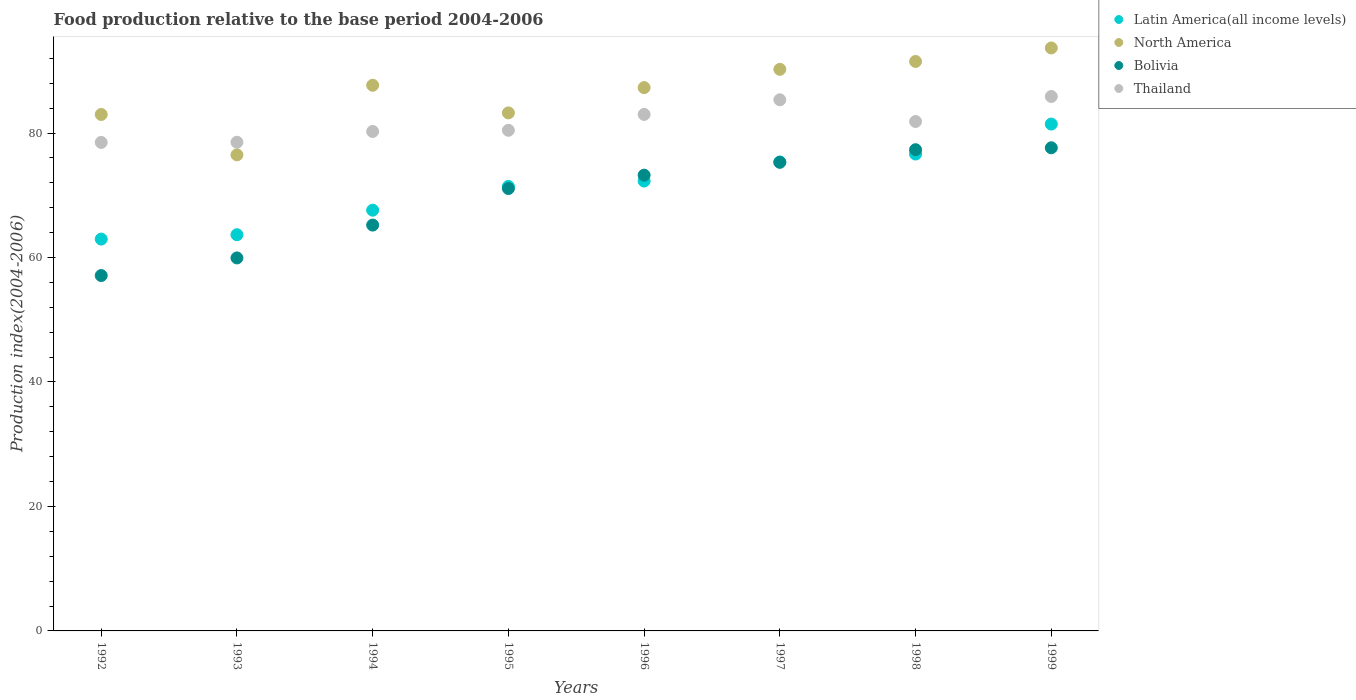What is the food production index in Thailand in 1997?
Your response must be concise. 85.34. Across all years, what is the maximum food production index in North America?
Ensure brevity in your answer.  93.67. Across all years, what is the minimum food production index in Thailand?
Your response must be concise. 78.49. In which year was the food production index in North America minimum?
Your response must be concise. 1993. What is the total food production index in Bolivia in the graph?
Give a very brief answer. 556.8. What is the difference between the food production index in Latin America(all income levels) in 1992 and that in 1998?
Provide a succinct answer. -13.67. What is the difference between the food production index in Latin America(all income levels) in 1992 and the food production index in Bolivia in 1999?
Your answer should be very brief. -14.67. What is the average food production index in Latin America(all income levels) per year?
Provide a short and direct response. 71.42. In the year 1993, what is the difference between the food production index in North America and food production index in Bolivia?
Ensure brevity in your answer.  16.56. In how many years, is the food production index in Thailand greater than 52?
Your answer should be compact. 8. What is the ratio of the food production index in North America in 1993 to that in 1996?
Your answer should be very brief. 0.88. What is the difference between the highest and the second highest food production index in Latin America(all income levels)?
Offer a very short reply. 4.81. What is the difference between the highest and the lowest food production index in Thailand?
Your answer should be compact. 7.38. Is it the case that in every year, the sum of the food production index in Bolivia and food production index in Latin America(all income levels)  is greater than the sum of food production index in North America and food production index in Thailand?
Your answer should be very brief. No. Is the food production index in Bolivia strictly less than the food production index in Latin America(all income levels) over the years?
Keep it short and to the point. No. How many dotlines are there?
Ensure brevity in your answer.  4. What is the difference between two consecutive major ticks on the Y-axis?
Your response must be concise. 20. Does the graph contain any zero values?
Provide a short and direct response. No. Does the graph contain grids?
Keep it short and to the point. No. Where does the legend appear in the graph?
Offer a very short reply. Top right. How are the legend labels stacked?
Ensure brevity in your answer.  Vertical. What is the title of the graph?
Your answer should be very brief. Food production relative to the base period 2004-2006. What is the label or title of the X-axis?
Keep it short and to the point. Years. What is the label or title of the Y-axis?
Give a very brief answer. Production index(2004-2006). What is the Production index(2004-2006) in Latin America(all income levels) in 1992?
Offer a terse response. 62.96. What is the Production index(2004-2006) in North America in 1992?
Your answer should be very brief. 82.98. What is the Production index(2004-2006) in Bolivia in 1992?
Ensure brevity in your answer.  57.1. What is the Production index(2004-2006) in Thailand in 1992?
Your response must be concise. 78.49. What is the Production index(2004-2006) in Latin America(all income levels) in 1993?
Ensure brevity in your answer.  63.66. What is the Production index(2004-2006) in North America in 1993?
Make the answer very short. 76.49. What is the Production index(2004-2006) in Bolivia in 1993?
Your answer should be compact. 59.93. What is the Production index(2004-2006) of Thailand in 1993?
Ensure brevity in your answer.  78.52. What is the Production index(2004-2006) in Latin America(all income levels) in 1994?
Ensure brevity in your answer.  67.6. What is the Production index(2004-2006) of North America in 1994?
Give a very brief answer. 87.67. What is the Production index(2004-2006) in Bolivia in 1994?
Your answer should be very brief. 65.21. What is the Production index(2004-2006) of Thailand in 1994?
Offer a very short reply. 80.25. What is the Production index(2004-2006) in Latin America(all income levels) in 1995?
Your answer should be compact. 71.42. What is the Production index(2004-2006) in North America in 1995?
Offer a very short reply. 83.24. What is the Production index(2004-2006) of Bolivia in 1995?
Offer a very short reply. 71.08. What is the Production index(2004-2006) of Thailand in 1995?
Your answer should be very brief. 80.44. What is the Production index(2004-2006) in Latin America(all income levels) in 1996?
Provide a short and direct response. 72.28. What is the Production index(2004-2006) of North America in 1996?
Your answer should be compact. 87.3. What is the Production index(2004-2006) in Bolivia in 1996?
Your answer should be compact. 73.23. What is the Production index(2004-2006) of Thailand in 1996?
Offer a terse response. 82.99. What is the Production index(2004-2006) in Latin America(all income levels) in 1997?
Your answer should be compact. 75.34. What is the Production index(2004-2006) of North America in 1997?
Give a very brief answer. 90.24. What is the Production index(2004-2006) of Bolivia in 1997?
Make the answer very short. 75.3. What is the Production index(2004-2006) of Thailand in 1997?
Provide a short and direct response. 85.34. What is the Production index(2004-2006) of Latin America(all income levels) in 1998?
Your response must be concise. 76.63. What is the Production index(2004-2006) in North America in 1998?
Provide a short and direct response. 91.5. What is the Production index(2004-2006) in Bolivia in 1998?
Your answer should be very brief. 77.32. What is the Production index(2004-2006) of Thailand in 1998?
Your answer should be compact. 81.85. What is the Production index(2004-2006) of Latin America(all income levels) in 1999?
Your answer should be very brief. 81.44. What is the Production index(2004-2006) of North America in 1999?
Provide a short and direct response. 93.67. What is the Production index(2004-2006) in Bolivia in 1999?
Your answer should be very brief. 77.63. What is the Production index(2004-2006) in Thailand in 1999?
Provide a succinct answer. 85.87. Across all years, what is the maximum Production index(2004-2006) in Latin America(all income levels)?
Keep it short and to the point. 81.44. Across all years, what is the maximum Production index(2004-2006) in North America?
Your answer should be very brief. 93.67. Across all years, what is the maximum Production index(2004-2006) of Bolivia?
Offer a terse response. 77.63. Across all years, what is the maximum Production index(2004-2006) in Thailand?
Keep it short and to the point. 85.87. Across all years, what is the minimum Production index(2004-2006) in Latin America(all income levels)?
Your response must be concise. 62.96. Across all years, what is the minimum Production index(2004-2006) in North America?
Provide a short and direct response. 76.49. Across all years, what is the minimum Production index(2004-2006) of Bolivia?
Your answer should be very brief. 57.1. Across all years, what is the minimum Production index(2004-2006) in Thailand?
Make the answer very short. 78.49. What is the total Production index(2004-2006) of Latin America(all income levels) in the graph?
Ensure brevity in your answer.  571.34. What is the total Production index(2004-2006) in North America in the graph?
Your answer should be compact. 693.08. What is the total Production index(2004-2006) of Bolivia in the graph?
Your answer should be compact. 556.8. What is the total Production index(2004-2006) of Thailand in the graph?
Make the answer very short. 653.75. What is the difference between the Production index(2004-2006) in Latin America(all income levels) in 1992 and that in 1993?
Offer a very short reply. -0.7. What is the difference between the Production index(2004-2006) of North America in 1992 and that in 1993?
Ensure brevity in your answer.  6.49. What is the difference between the Production index(2004-2006) in Bolivia in 1992 and that in 1993?
Provide a succinct answer. -2.83. What is the difference between the Production index(2004-2006) of Thailand in 1992 and that in 1993?
Your answer should be compact. -0.03. What is the difference between the Production index(2004-2006) in Latin America(all income levels) in 1992 and that in 1994?
Make the answer very short. -4.64. What is the difference between the Production index(2004-2006) of North America in 1992 and that in 1994?
Provide a succinct answer. -4.69. What is the difference between the Production index(2004-2006) of Bolivia in 1992 and that in 1994?
Your answer should be very brief. -8.11. What is the difference between the Production index(2004-2006) of Thailand in 1992 and that in 1994?
Provide a short and direct response. -1.76. What is the difference between the Production index(2004-2006) in Latin America(all income levels) in 1992 and that in 1995?
Make the answer very short. -8.46. What is the difference between the Production index(2004-2006) in North America in 1992 and that in 1995?
Your response must be concise. -0.26. What is the difference between the Production index(2004-2006) in Bolivia in 1992 and that in 1995?
Give a very brief answer. -13.98. What is the difference between the Production index(2004-2006) in Thailand in 1992 and that in 1995?
Offer a very short reply. -1.95. What is the difference between the Production index(2004-2006) in Latin America(all income levels) in 1992 and that in 1996?
Ensure brevity in your answer.  -9.32. What is the difference between the Production index(2004-2006) in North America in 1992 and that in 1996?
Offer a very short reply. -4.32. What is the difference between the Production index(2004-2006) in Bolivia in 1992 and that in 1996?
Offer a very short reply. -16.13. What is the difference between the Production index(2004-2006) of Thailand in 1992 and that in 1996?
Give a very brief answer. -4.5. What is the difference between the Production index(2004-2006) of Latin America(all income levels) in 1992 and that in 1997?
Provide a short and direct response. -12.38. What is the difference between the Production index(2004-2006) of North America in 1992 and that in 1997?
Ensure brevity in your answer.  -7.25. What is the difference between the Production index(2004-2006) in Bolivia in 1992 and that in 1997?
Make the answer very short. -18.2. What is the difference between the Production index(2004-2006) of Thailand in 1992 and that in 1997?
Provide a short and direct response. -6.85. What is the difference between the Production index(2004-2006) in Latin America(all income levels) in 1992 and that in 1998?
Provide a succinct answer. -13.67. What is the difference between the Production index(2004-2006) of North America in 1992 and that in 1998?
Give a very brief answer. -8.52. What is the difference between the Production index(2004-2006) of Bolivia in 1992 and that in 1998?
Your answer should be very brief. -20.22. What is the difference between the Production index(2004-2006) in Thailand in 1992 and that in 1998?
Keep it short and to the point. -3.36. What is the difference between the Production index(2004-2006) in Latin America(all income levels) in 1992 and that in 1999?
Offer a terse response. -18.48. What is the difference between the Production index(2004-2006) in North America in 1992 and that in 1999?
Make the answer very short. -10.69. What is the difference between the Production index(2004-2006) of Bolivia in 1992 and that in 1999?
Offer a very short reply. -20.53. What is the difference between the Production index(2004-2006) of Thailand in 1992 and that in 1999?
Make the answer very short. -7.38. What is the difference between the Production index(2004-2006) of Latin America(all income levels) in 1993 and that in 1994?
Your answer should be compact. -3.94. What is the difference between the Production index(2004-2006) in North America in 1993 and that in 1994?
Offer a terse response. -11.18. What is the difference between the Production index(2004-2006) in Bolivia in 1993 and that in 1994?
Make the answer very short. -5.28. What is the difference between the Production index(2004-2006) of Thailand in 1993 and that in 1994?
Provide a short and direct response. -1.73. What is the difference between the Production index(2004-2006) in Latin America(all income levels) in 1993 and that in 1995?
Offer a terse response. -7.76. What is the difference between the Production index(2004-2006) in North America in 1993 and that in 1995?
Make the answer very short. -6.74. What is the difference between the Production index(2004-2006) of Bolivia in 1993 and that in 1995?
Offer a very short reply. -11.15. What is the difference between the Production index(2004-2006) of Thailand in 1993 and that in 1995?
Your answer should be compact. -1.92. What is the difference between the Production index(2004-2006) of Latin America(all income levels) in 1993 and that in 1996?
Provide a short and direct response. -8.62. What is the difference between the Production index(2004-2006) in North America in 1993 and that in 1996?
Your answer should be very brief. -10.8. What is the difference between the Production index(2004-2006) in Thailand in 1993 and that in 1996?
Offer a very short reply. -4.47. What is the difference between the Production index(2004-2006) in Latin America(all income levels) in 1993 and that in 1997?
Provide a succinct answer. -11.68. What is the difference between the Production index(2004-2006) in North America in 1993 and that in 1997?
Your answer should be compact. -13.74. What is the difference between the Production index(2004-2006) of Bolivia in 1993 and that in 1997?
Make the answer very short. -15.37. What is the difference between the Production index(2004-2006) of Thailand in 1993 and that in 1997?
Ensure brevity in your answer.  -6.82. What is the difference between the Production index(2004-2006) of Latin America(all income levels) in 1993 and that in 1998?
Offer a terse response. -12.96. What is the difference between the Production index(2004-2006) in North America in 1993 and that in 1998?
Ensure brevity in your answer.  -15.01. What is the difference between the Production index(2004-2006) in Bolivia in 1993 and that in 1998?
Provide a short and direct response. -17.39. What is the difference between the Production index(2004-2006) of Thailand in 1993 and that in 1998?
Make the answer very short. -3.33. What is the difference between the Production index(2004-2006) in Latin America(all income levels) in 1993 and that in 1999?
Offer a very short reply. -17.78. What is the difference between the Production index(2004-2006) in North America in 1993 and that in 1999?
Ensure brevity in your answer.  -17.18. What is the difference between the Production index(2004-2006) of Bolivia in 1993 and that in 1999?
Your answer should be very brief. -17.7. What is the difference between the Production index(2004-2006) in Thailand in 1993 and that in 1999?
Ensure brevity in your answer.  -7.35. What is the difference between the Production index(2004-2006) in Latin America(all income levels) in 1994 and that in 1995?
Your answer should be very brief. -3.82. What is the difference between the Production index(2004-2006) of North America in 1994 and that in 1995?
Your answer should be compact. 4.44. What is the difference between the Production index(2004-2006) in Bolivia in 1994 and that in 1995?
Ensure brevity in your answer.  -5.87. What is the difference between the Production index(2004-2006) of Thailand in 1994 and that in 1995?
Offer a terse response. -0.19. What is the difference between the Production index(2004-2006) of Latin America(all income levels) in 1994 and that in 1996?
Your response must be concise. -4.68. What is the difference between the Production index(2004-2006) of North America in 1994 and that in 1996?
Keep it short and to the point. 0.38. What is the difference between the Production index(2004-2006) of Bolivia in 1994 and that in 1996?
Ensure brevity in your answer.  -8.02. What is the difference between the Production index(2004-2006) in Thailand in 1994 and that in 1996?
Your answer should be compact. -2.74. What is the difference between the Production index(2004-2006) in Latin America(all income levels) in 1994 and that in 1997?
Give a very brief answer. -7.74. What is the difference between the Production index(2004-2006) in North America in 1994 and that in 1997?
Make the answer very short. -2.56. What is the difference between the Production index(2004-2006) in Bolivia in 1994 and that in 1997?
Offer a very short reply. -10.09. What is the difference between the Production index(2004-2006) of Thailand in 1994 and that in 1997?
Keep it short and to the point. -5.09. What is the difference between the Production index(2004-2006) of Latin America(all income levels) in 1994 and that in 1998?
Provide a succinct answer. -9.02. What is the difference between the Production index(2004-2006) of North America in 1994 and that in 1998?
Ensure brevity in your answer.  -3.83. What is the difference between the Production index(2004-2006) of Bolivia in 1994 and that in 1998?
Make the answer very short. -12.11. What is the difference between the Production index(2004-2006) in Latin America(all income levels) in 1994 and that in 1999?
Offer a very short reply. -13.84. What is the difference between the Production index(2004-2006) in North America in 1994 and that in 1999?
Ensure brevity in your answer.  -6. What is the difference between the Production index(2004-2006) in Bolivia in 1994 and that in 1999?
Ensure brevity in your answer.  -12.42. What is the difference between the Production index(2004-2006) of Thailand in 1994 and that in 1999?
Provide a succinct answer. -5.62. What is the difference between the Production index(2004-2006) of Latin America(all income levels) in 1995 and that in 1996?
Offer a very short reply. -0.86. What is the difference between the Production index(2004-2006) in North America in 1995 and that in 1996?
Make the answer very short. -4.06. What is the difference between the Production index(2004-2006) in Bolivia in 1995 and that in 1996?
Offer a very short reply. -2.15. What is the difference between the Production index(2004-2006) in Thailand in 1995 and that in 1996?
Offer a very short reply. -2.55. What is the difference between the Production index(2004-2006) in Latin America(all income levels) in 1995 and that in 1997?
Offer a very short reply. -3.92. What is the difference between the Production index(2004-2006) in North America in 1995 and that in 1997?
Make the answer very short. -7. What is the difference between the Production index(2004-2006) in Bolivia in 1995 and that in 1997?
Provide a succinct answer. -4.22. What is the difference between the Production index(2004-2006) in Latin America(all income levels) in 1995 and that in 1998?
Offer a terse response. -5.21. What is the difference between the Production index(2004-2006) in North America in 1995 and that in 1998?
Offer a very short reply. -8.27. What is the difference between the Production index(2004-2006) in Bolivia in 1995 and that in 1998?
Offer a very short reply. -6.24. What is the difference between the Production index(2004-2006) in Thailand in 1995 and that in 1998?
Offer a terse response. -1.41. What is the difference between the Production index(2004-2006) of Latin America(all income levels) in 1995 and that in 1999?
Provide a succinct answer. -10.02. What is the difference between the Production index(2004-2006) of North America in 1995 and that in 1999?
Provide a succinct answer. -10.43. What is the difference between the Production index(2004-2006) of Bolivia in 1995 and that in 1999?
Your answer should be compact. -6.55. What is the difference between the Production index(2004-2006) in Thailand in 1995 and that in 1999?
Provide a succinct answer. -5.43. What is the difference between the Production index(2004-2006) of Latin America(all income levels) in 1996 and that in 1997?
Provide a succinct answer. -3.06. What is the difference between the Production index(2004-2006) of North America in 1996 and that in 1997?
Offer a very short reply. -2.94. What is the difference between the Production index(2004-2006) in Bolivia in 1996 and that in 1997?
Give a very brief answer. -2.07. What is the difference between the Production index(2004-2006) of Thailand in 1996 and that in 1997?
Keep it short and to the point. -2.35. What is the difference between the Production index(2004-2006) of Latin America(all income levels) in 1996 and that in 1998?
Offer a very short reply. -4.34. What is the difference between the Production index(2004-2006) in North America in 1996 and that in 1998?
Make the answer very short. -4.21. What is the difference between the Production index(2004-2006) in Bolivia in 1996 and that in 1998?
Offer a very short reply. -4.09. What is the difference between the Production index(2004-2006) of Thailand in 1996 and that in 1998?
Keep it short and to the point. 1.14. What is the difference between the Production index(2004-2006) in Latin America(all income levels) in 1996 and that in 1999?
Ensure brevity in your answer.  -9.16. What is the difference between the Production index(2004-2006) in North America in 1996 and that in 1999?
Provide a short and direct response. -6.37. What is the difference between the Production index(2004-2006) in Thailand in 1996 and that in 1999?
Ensure brevity in your answer.  -2.88. What is the difference between the Production index(2004-2006) of Latin America(all income levels) in 1997 and that in 1998?
Provide a succinct answer. -1.28. What is the difference between the Production index(2004-2006) of North America in 1997 and that in 1998?
Your answer should be very brief. -1.27. What is the difference between the Production index(2004-2006) in Bolivia in 1997 and that in 1998?
Provide a succinct answer. -2.02. What is the difference between the Production index(2004-2006) of Thailand in 1997 and that in 1998?
Ensure brevity in your answer.  3.49. What is the difference between the Production index(2004-2006) in Latin America(all income levels) in 1997 and that in 1999?
Your response must be concise. -6.1. What is the difference between the Production index(2004-2006) of North America in 1997 and that in 1999?
Your answer should be compact. -3.43. What is the difference between the Production index(2004-2006) of Bolivia in 1997 and that in 1999?
Provide a short and direct response. -2.33. What is the difference between the Production index(2004-2006) in Thailand in 1997 and that in 1999?
Offer a terse response. -0.53. What is the difference between the Production index(2004-2006) of Latin America(all income levels) in 1998 and that in 1999?
Make the answer very short. -4.81. What is the difference between the Production index(2004-2006) in North America in 1998 and that in 1999?
Provide a short and direct response. -2.17. What is the difference between the Production index(2004-2006) of Bolivia in 1998 and that in 1999?
Your response must be concise. -0.31. What is the difference between the Production index(2004-2006) of Thailand in 1998 and that in 1999?
Your answer should be very brief. -4.02. What is the difference between the Production index(2004-2006) in Latin America(all income levels) in 1992 and the Production index(2004-2006) in North America in 1993?
Make the answer very short. -13.53. What is the difference between the Production index(2004-2006) of Latin America(all income levels) in 1992 and the Production index(2004-2006) of Bolivia in 1993?
Your answer should be very brief. 3.03. What is the difference between the Production index(2004-2006) in Latin America(all income levels) in 1992 and the Production index(2004-2006) in Thailand in 1993?
Ensure brevity in your answer.  -15.56. What is the difference between the Production index(2004-2006) in North America in 1992 and the Production index(2004-2006) in Bolivia in 1993?
Make the answer very short. 23.05. What is the difference between the Production index(2004-2006) of North America in 1992 and the Production index(2004-2006) of Thailand in 1993?
Your answer should be compact. 4.46. What is the difference between the Production index(2004-2006) in Bolivia in 1992 and the Production index(2004-2006) in Thailand in 1993?
Your answer should be very brief. -21.42. What is the difference between the Production index(2004-2006) in Latin America(all income levels) in 1992 and the Production index(2004-2006) in North America in 1994?
Ensure brevity in your answer.  -24.71. What is the difference between the Production index(2004-2006) in Latin America(all income levels) in 1992 and the Production index(2004-2006) in Bolivia in 1994?
Keep it short and to the point. -2.25. What is the difference between the Production index(2004-2006) in Latin America(all income levels) in 1992 and the Production index(2004-2006) in Thailand in 1994?
Provide a short and direct response. -17.29. What is the difference between the Production index(2004-2006) in North America in 1992 and the Production index(2004-2006) in Bolivia in 1994?
Give a very brief answer. 17.77. What is the difference between the Production index(2004-2006) in North America in 1992 and the Production index(2004-2006) in Thailand in 1994?
Provide a short and direct response. 2.73. What is the difference between the Production index(2004-2006) in Bolivia in 1992 and the Production index(2004-2006) in Thailand in 1994?
Your answer should be very brief. -23.15. What is the difference between the Production index(2004-2006) of Latin America(all income levels) in 1992 and the Production index(2004-2006) of North America in 1995?
Offer a terse response. -20.28. What is the difference between the Production index(2004-2006) in Latin America(all income levels) in 1992 and the Production index(2004-2006) in Bolivia in 1995?
Ensure brevity in your answer.  -8.12. What is the difference between the Production index(2004-2006) of Latin America(all income levels) in 1992 and the Production index(2004-2006) of Thailand in 1995?
Provide a short and direct response. -17.48. What is the difference between the Production index(2004-2006) of North America in 1992 and the Production index(2004-2006) of Bolivia in 1995?
Offer a terse response. 11.9. What is the difference between the Production index(2004-2006) of North America in 1992 and the Production index(2004-2006) of Thailand in 1995?
Offer a very short reply. 2.54. What is the difference between the Production index(2004-2006) of Bolivia in 1992 and the Production index(2004-2006) of Thailand in 1995?
Provide a short and direct response. -23.34. What is the difference between the Production index(2004-2006) in Latin America(all income levels) in 1992 and the Production index(2004-2006) in North America in 1996?
Keep it short and to the point. -24.34. What is the difference between the Production index(2004-2006) of Latin America(all income levels) in 1992 and the Production index(2004-2006) of Bolivia in 1996?
Offer a very short reply. -10.27. What is the difference between the Production index(2004-2006) of Latin America(all income levels) in 1992 and the Production index(2004-2006) of Thailand in 1996?
Provide a short and direct response. -20.03. What is the difference between the Production index(2004-2006) of North America in 1992 and the Production index(2004-2006) of Bolivia in 1996?
Ensure brevity in your answer.  9.75. What is the difference between the Production index(2004-2006) in North America in 1992 and the Production index(2004-2006) in Thailand in 1996?
Your answer should be very brief. -0.01. What is the difference between the Production index(2004-2006) of Bolivia in 1992 and the Production index(2004-2006) of Thailand in 1996?
Make the answer very short. -25.89. What is the difference between the Production index(2004-2006) in Latin America(all income levels) in 1992 and the Production index(2004-2006) in North America in 1997?
Give a very brief answer. -27.27. What is the difference between the Production index(2004-2006) of Latin America(all income levels) in 1992 and the Production index(2004-2006) of Bolivia in 1997?
Your answer should be compact. -12.34. What is the difference between the Production index(2004-2006) of Latin America(all income levels) in 1992 and the Production index(2004-2006) of Thailand in 1997?
Keep it short and to the point. -22.38. What is the difference between the Production index(2004-2006) in North America in 1992 and the Production index(2004-2006) in Bolivia in 1997?
Ensure brevity in your answer.  7.68. What is the difference between the Production index(2004-2006) in North America in 1992 and the Production index(2004-2006) in Thailand in 1997?
Offer a terse response. -2.36. What is the difference between the Production index(2004-2006) in Bolivia in 1992 and the Production index(2004-2006) in Thailand in 1997?
Give a very brief answer. -28.24. What is the difference between the Production index(2004-2006) of Latin America(all income levels) in 1992 and the Production index(2004-2006) of North America in 1998?
Your response must be concise. -28.54. What is the difference between the Production index(2004-2006) in Latin America(all income levels) in 1992 and the Production index(2004-2006) in Bolivia in 1998?
Your response must be concise. -14.36. What is the difference between the Production index(2004-2006) in Latin America(all income levels) in 1992 and the Production index(2004-2006) in Thailand in 1998?
Make the answer very short. -18.89. What is the difference between the Production index(2004-2006) of North America in 1992 and the Production index(2004-2006) of Bolivia in 1998?
Your response must be concise. 5.66. What is the difference between the Production index(2004-2006) in North America in 1992 and the Production index(2004-2006) in Thailand in 1998?
Offer a terse response. 1.13. What is the difference between the Production index(2004-2006) of Bolivia in 1992 and the Production index(2004-2006) of Thailand in 1998?
Ensure brevity in your answer.  -24.75. What is the difference between the Production index(2004-2006) of Latin America(all income levels) in 1992 and the Production index(2004-2006) of North America in 1999?
Ensure brevity in your answer.  -30.71. What is the difference between the Production index(2004-2006) of Latin America(all income levels) in 1992 and the Production index(2004-2006) of Bolivia in 1999?
Your answer should be very brief. -14.67. What is the difference between the Production index(2004-2006) of Latin America(all income levels) in 1992 and the Production index(2004-2006) of Thailand in 1999?
Give a very brief answer. -22.91. What is the difference between the Production index(2004-2006) in North America in 1992 and the Production index(2004-2006) in Bolivia in 1999?
Keep it short and to the point. 5.35. What is the difference between the Production index(2004-2006) of North America in 1992 and the Production index(2004-2006) of Thailand in 1999?
Provide a succinct answer. -2.89. What is the difference between the Production index(2004-2006) of Bolivia in 1992 and the Production index(2004-2006) of Thailand in 1999?
Provide a short and direct response. -28.77. What is the difference between the Production index(2004-2006) of Latin America(all income levels) in 1993 and the Production index(2004-2006) of North America in 1994?
Make the answer very short. -24.01. What is the difference between the Production index(2004-2006) in Latin America(all income levels) in 1993 and the Production index(2004-2006) in Bolivia in 1994?
Provide a succinct answer. -1.55. What is the difference between the Production index(2004-2006) in Latin America(all income levels) in 1993 and the Production index(2004-2006) in Thailand in 1994?
Offer a very short reply. -16.59. What is the difference between the Production index(2004-2006) of North America in 1993 and the Production index(2004-2006) of Bolivia in 1994?
Make the answer very short. 11.28. What is the difference between the Production index(2004-2006) in North America in 1993 and the Production index(2004-2006) in Thailand in 1994?
Offer a very short reply. -3.76. What is the difference between the Production index(2004-2006) in Bolivia in 1993 and the Production index(2004-2006) in Thailand in 1994?
Keep it short and to the point. -20.32. What is the difference between the Production index(2004-2006) of Latin America(all income levels) in 1993 and the Production index(2004-2006) of North America in 1995?
Offer a terse response. -19.57. What is the difference between the Production index(2004-2006) of Latin America(all income levels) in 1993 and the Production index(2004-2006) of Bolivia in 1995?
Your response must be concise. -7.42. What is the difference between the Production index(2004-2006) in Latin America(all income levels) in 1993 and the Production index(2004-2006) in Thailand in 1995?
Provide a succinct answer. -16.78. What is the difference between the Production index(2004-2006) in North America in 1993 and the Production index(2004-2006) in Bolivia in 1995?
Offer a terse response. 5.41. What is the difference between the Production index(2004-2006) in North America in 1993 and the Production index(2004-2006) in Thailand in 1995?
Give a very brief answer. -3.95. What is the difference between the Production index(2004-2006) of Bolivia in 1993 and the Production index(2004-2006) of Thailand in 1995?
Offer a very short reply. -20.51. What is the difference between the Production index(2004-2006) in Latin America(all income levels) in 1993 and the Production index(2004-2006) in North America in 1996?
Keep it short and to the point. -23.63. What is the difference between the Production index(2004-2006) of Latin America(all income levels) in 1993 and the Production index(2004-2006) of Bolivia in 1996?
Keep it short and to the point. -9.57. What is the difference between the Production index(2004-2006) of Latin America(all income levels) in 1993 and the Production index(2004-2006) of Thailand in 1996?
Offer a terse response. -19.33. What is the difference between the Production index(2004-2006) of North America in 1993 and the Production index(2004-2006) of Bolivia in 1996?
Your response must be concise. 3.26. What is the difference between the Production index(2004-2006) of North America in 1993 and the Production index(2004-2006) of Thailand in 1996?
Offer a very short reply. -6.5. What is the difference between the Production index(2004-2006) of Bolivia in 1993 and the Production index(2004-2006) of Thailand in 1996?
Give a very brief answer. -23.06. What is the difference between the Production index(2004-2006) in Latin America(all income levels) in 1993 and the Production index(2004-2006) in North America in 1997?
Your response must be concise. -26.57. What is the difference between the Production index(2004-2006) of Latin America(all income levels) in 1993 and the Production index(2004-2006) of Bolivia in 1997?
Ensure brevity in your answer.  -11.64. What is the difference between the Production index(2004-2006) of Latin America(all income levels) in 1993 and the Production index(2004-2006) of Thailand in 1997?
Make the answer very short. -21.68. What is the difference between the Production index(2004-2006) in North America in 1993 and the Production index(2004-2006) in Bolivia in 1997?
Keep it short and to the point. 1.19. What is the difference between the Production index(2004-2006) in North America in 1993 and the Production index(2004-2006) in Thailand in 1997?
Provide a succinct answer. -8.85. What is the difference between the Production index(2004-2006) of Bolivia in 1993 and the Production index(2004-2006) of Thailand in 1997?
Your answer should be very brief. -25.41. What is the difference between the Production index(2004-2006) of Latin America(all income levels) in 1993 and the Production index(2004-2006) of North America in 1998?
Offer a terse response. -27.84. What is the difference between the Production index(2004-2006) in Latin America(all income levels) in 1993 and the Production index(2004-2006) in Bolivia in 1998?
Offer a very short reply. -13.66. What is the difference between the Production index(2004-2006) in Latin America(all income levels) in 1993 and the Production index(2004-2006) in Thailand in 1998?
Make the answer very short. -18.19. What is the difference between the Production index(2004-2006) of North America in 1993 and the Production index(2004-2006) of Bolivia in 1998?
Your response must be concise. -0.83. What is the difference between the Production index(2004-2006) in North America in 1993 and the Production index(2004-2006) in Thailand in 1998?
Make the answer very short. -5.36. What is the difference between the Production index(2004-2006) of Bolivia in 1993 and the Production index(2004-2006) of Thailand in 1998?
Offer a terse response. -21.92. What is the difference between the Production index(2004-2006) of Latin America(all income levels) in 1993 and the Production index(2004-2006) of North America in 1999?
Offer a terse response. -30.01. What is the difference between the Production index(2004-2006) of Latin America(all income levels) in 1993 and the Production index(2004-2006) of Bolivia in 1999?
Give a very brief answer. -13.97. What is the difference between the Production index(2004-2006) in Latin America(all income levels) in 1993 and the Production index(2004-2006) in Thailand in 1999?
Your answer should be very brief. -22.21. What is the difference between the Production index(2004-2006) of North America in 1993 and the Production index(2004-2006) of Bolivia in 1999?
Provide a short and direct response. -1.14. What is the difference between the Production index(2004-2006) in North America in 1993 and the Production index(2004-2006) in Thailand in 1999?
Your answer should be very brief. -9.38. What is the difference between the Production index(2004-2006) in Bolivia in 1993 and the Production index(2004-2006) in Thailand in 1999?
Give a very brief answer. -25.94. What is the difference between the Production index(2004-2006) of Latin America(all income levels) in 1994 and the Production index(2004-2006) of North America in 1995?
Offer a very short reply. -15.63. What is the difference between the Production index(2004-2006) in Latin America(all income levels) in 1994 and the Production index(2004-2006) in Bolivia in 1995?
Give a very brief answer. -3.48. What is the difference between the Production index(2004-2006) of Latin America(all income levels) in 1994 and the Production index(2004-2006) of Thailand in 1995?
Offer a terse response. -12.84. What is the difference between the Production index(2004-2006) in North America in 1994 and the Production index(2004-2006) in Bolivia in 1995?
Your answer should be very brief. 16.59. What is the difference between the Production index(2004-2006) of North America in 1994 and the Production index(2004-2006) of Thailand in 1995?
Make the answer very short. 7.23. What is the difference between the Production index(2004-2006) of Bolivia in 1994 and the Production index(2004-2006) of Thailand in 1995?
Offer a terse response. -15.23. What is the difference between the Production index(2004-2006) of Latin America(all income levels) in 1994 and the Production index(2004-2006) of North America in 1996?
Keep it short and to the point. -19.69. What is the difference between the Production index(2004-2006) in Latin America(all income levels) in 1994 and the Production index(2004-2006) in Bolivia in 1996?
Your answer should be very brief. -5.63. What is the difference between the Production index(2004-2006) of Latin America(all income levels) in 1994 and the Production index(2004-2006) of Thailand in 1996?
Your answer should be very brief. -15.39. What is the difference between the Production index(2004-2006) of North America in 1994 and the Production index(2004-2006) of Bolivia in 1996?
Keep it short and to the point. 14.44. What is the difference between the Production index(2004-2006) in North America in 1994 and the Production index(2004-2006) in Thailand in 1996?
Provide a short and direct response. 4.68. What is the difference between the Production index(2004-2006) of Bolivia in 1994 and the Production index(2004-2006) of Thailand in 1996?
Your answer should be very brief. -17.78. What is the difference between the Production index(2004-2006) of Latin America(all income levels) in 1994 and the Production index(2004-2006) of North America in 1997?
Provide a short and direct response. -22.63. What is the difference between the Production index(2004-2006) in Latin America(all income levels) in 1994 and the Production index(2004-2006) in Bolivia in 1997?
Your response must be concise. -7.7. What is the difference between the Production index(2004-2006) in Latin America(all income levels) in 1994 and the Production index(2004-2006) in Thailand in 1997?
Your response must be concise. -17.74. What is the difference between the Production index(2004-2006) of North America in 1994 and the Production index(2004-2006) of Bolivia in 1997?
Your response must be concise. 12.37. What is the difference between the Production index(2004-2006) of North America in 1994 and the Production index(2004-2006) of Thailand in 1997?
Give a very brief answer. 2.33. What is the difference between the Production index(2004-2006) in Bolivia in 1994 and the Production index(2004-2006) in Thailand in 1997?
Make the answer very short. -20.13. What is the difference between the Production index(2004-2006) of Latin America(all income levels) in 1994 and the Production index(2004-2006) of North America in 1998?
Keep it short and to the point. -23.9. What is the difference between the Production index(2004-2006) in Latin America(all income levels) in 1994 and the Production index(2004-2006) in Bolivia in 1998?
Your answer should be compact. -9.72. What is the difference between the Production index(2004-2006) of Latin America(all income levels) in 1994 and the Production index(2004-2006) of Thailand in 1998?
Your answer should be compact. -14.25. What is the difference between the Production index(2004-2006) in North America in 1994 and the Production index(2004-2006) in Bolivia in 1998?
Give a very brief answer. 10.35. What is the difference between the Production index(2004-2006) of North America in 1994 and the Production index(2004-2006) of Thailand in 1998?
Give a very brief answer. 5.82. What is the difference between the Production index(2004-2006) in Bolivia in 1994 and the Production index(2004-2006) in Thailand in 1998?
Provide a succinct answer. -16.64. What is the difference between the Production index(2004-2006) of Latin America(all income levels) in 1994 and the Production index(2004-2006) of North America in 1999?
Your answer should be compact. -26.07. What is the difference between the Production index(2004-2006) of Latin America(all income levels) in 1994 and the Production index(2004-2006) of Bolivia in 1999?
Make the answer very short. -10.03. What is the difference between the Production index(2004-2006) in Latin America(all income levels) in 1994 and the Production index(2004-2006) in Thailand in 1999?
Your answer should be very brief. -18.27. What is the difference between the Production index(2004-2006) in North America in 1994 and the Production index(2004-2006) in Bolivia in 1999?
Ensure brevity in your answer.  10.04. What is the difference between the Production index(2004-2006) in North America in 1994 and the Production index(2004-2006) in Thailand in 1999?
Keep it short and to the point. 1.8. What is the difference between the Production index(2004-2006) in Bolivia in 1994 and the Production index(2004-2006) in Thailand in 1999?
Ensure brevity in your answer.  -20.66. What is the difference between the Production index(2004-2006) in Latin America(all income levels) in 1995 and the Production index(2004-2006) in North America in 1996?
Give a very brief answer. -15.88. What is the difference between the Production index(2004-2006) in Latin America(all income levels) in 1995 and the Production index(2004-2006) in Bolivia in 1996?
Keep it short and to the point. -1.81. What is the difference between the Production index(2004-2006) of Latin America(all income levels) in 1995 and the Production index(2004-2006) of Thailand in 1996?
Make the answer very short. -11.57. What is the difference between the Production index(2004-2006) of North America in 1995 and the Production index(2004-2006) of Bolivia in 1996?
Give a very brief answer. 10.01. What is the difference between the Production index(2004-2006) of North America in 1995 and the Production index(2004-2006) of Thailand in 1996?
Keep it short and to the point. 0.25. What is the difference between the Production index(2004-2006) in Bolivia in 1995 and the Production index(2004-2006) in Thailand in 1996?
Offer a very short reply. -11.91. What is the difference between the Production index(2004-2006) in Latin America(all income levels) in 1995 and the Production index(2004-2006) in North America in 1997?
Ensure brevity in your answer.  -18.82. What is the difference between the Production index(2004-2006) of Latin America(all income levels) in 1995 and the Production index(2004-2006) of Bolivia in 1997?
Provide a short and direct response. -3.88. What is the difference between the Production index(2004-2006) in Latin America(all income levels) in 1995 and the Production index(2004-2006) in Thailand in 1997?
Give a very brief answer. -13.92. What is the difference between the Production index(2004-2006) in North America in 1995 and the Production index(2004-2006) in Bolivia in 1997?
Your answer should be very brief. 7.94. What is the difference between the Production index(2004-2006) in North America in 1995 and the Production index(2004-2006) in Thailand in 1997?
Give a very brief answer. -2.1. What is the difference between the Production index(2004-2006) in Bolivia in 1995 and the Production index(2004-2006) in Thailand in 1997?
Provide a succinct answer. -14.26. What is the difference between the Production index(2004-2006) of Latin America(all income levels) in 1995 and the Production index(2004-2006) of North America in 1998?
Provide a succinct answer. -20.08. What is the difference between the Production index(2004-2006) in Latin America(all income levels) in 1995 and the Production index(2004-2006) in Bolivia in 1998?
Offer a terse response. -5.9. What is the difference between the Production index(2004-2006) in Latin America(all income levels) in 1995 and the Production index(2004-2006) in Thailand in 1998?
Make the answer very short. -10.43. What is the difference between the Production index(2004-2006) in North America in 1995 and the Production index(2004-2006) in Bolivia in 1998?
Keep it short and to the point. 5.92. What is the difference between the Production index(2004-2006) of North America in 1995 and the Production index(2004-2006) of Thailand in 1998?
Keep it short and to the point. 1.39. What is the difference between the Production index(2004-2006) of Bolivia in 1995 and the Production index(2004-2006) of Thailand in 1998?
Offer a very short reply. -10.77. What is the difference between the Production index(2004-2006) of Latin America(all income levels) in 1995 and the Production index(2004-2006) of North America in 1999?
Your answer should be compact. -22.25. What is the difference between the Production index(2004-2006) in Latin America(all income levels) in 1995 and the Production index(2004-2006) in Bolivia in 1999?
Offer a very short reply. -6.21. What is the difference between the Production index(2004-2006) in Latin America(all income levels) in 1995 and the Production index(2004-2006) in Thailand in 1999?
Provide a short and direct response. -14.45. What is the difference between the Production index(2004-2006) in North America in 1995 and the Production index(2004-2006) in Bolivia in 1999?
Your response must be concise. 5.61. What is the difference between the Production index(2004-2006) in North America in 1995 and the Production index(2004-2006) in Thailand in 1999?
Your response must be concise. -2.63. What is the difference between the Production index(2004-2006) in Bolivia in 1995 and the Production index(2004-2006) in Thailand in 1999?
Make the answer very short. -14.79. What is the difference between the Production index(2004-2006) of Latin America(all income levels) in 1996 and the Production index(2004-2006) of North America in 1997?
Your response must be concise. -17.95. What is the difference between the Production index(2004-2006) in Latin America(all income levels) in 1996 and the Production index(2004-2006) in Bolivia in 1997?
Offer a very short reply. -3.02. What is the difference between the Production index(2004-2006) in Latin America(all income levels) in 1996 and the Production index(2004-2006) in Thailand in 1997?
Ensure brevity in your answer.  -13.06. What is the difference between the Production index(2004-2006) of North America in 1996 and the Production index(2004-2006) of Bolivia in 1997?
Make the answer very short. 12. What is the difference between the Production index(2004-2006) of North America in 1996 and the Production index(2004-2006) of Thailand in 1997?
Make the answer very short. 1.96. What is the difference between the Production index(2004-2006) of Bolivia in 1996 and the Production index(2004-2006) of Thailand in 1997?
Your answer should be very brief. -12.11. What is the difference between the Production index(2004-2006) in Latin America(all income levels) in 1996 and the Production index(2004-2006) in North America in 1998?
Your answer should be very brief. -19.22. What is the difference between the Production index(2004-2006) of Latin America(all income levels) in 1996 and the Production index(2004-2006) of Bolivia in 1998?
Give a very brief answer. -5.04. What is the difference between the Production index(2004-2006) in Latin America(all income levels) in 1996 and the Production index(2004-2006) in Thailand in 1998?
Your response must be concise. -9.57. What is the difference between the Production index(2004-2006) in North America in 1996 and the Production index(2004-2006) in Bolivia in 1998?
Your answer should be compact. 9.98. What is the difference between the Production index(2004-2006) in North America in 1996 and the Production index(2004-2006) in Thailand in 1998?
Ensure brevity in your answer.  5.45. What is the difference between the Production index(2004-2006) in Bolivia in 1996 and the Production index(2004-2006) in Thailand in 1998?
Offer a very short reply. -8.62. What is the difference between the Production index(2004-2006) in Latin America(all income levels) in 1996 and the Production index(2004-2006) in North America in 1999?
Provide a short and direct response. -21.39. What is the difference between the Production index(2004-2006) in Latin America(all income levels) in 1996 and the Production index(2004-2006) in Bolivia in 1999?
Your answer should be very brief. -5.35. What is the difference between the Production index(2004-2006) of Latin America(all income levels) in 1996 and the Production index(2004-2006) of Thailand in 1999?
Provide a short and direct response. -13.59. What is the difference between the Production index(2004-2006) of North America in 1996 and the Production index(2004-2006) of Bolivia in 1999?
Offer a very short reply. 9.67. What is the difference between the Production index(2004-2006) of North America in 1996 and the Production index(2004-2006) of Thailand in 1999?
Provide a succinct answer. 1.43. What is the difference between the Production index(2004-2006) in Bolivia in 1996 and the Production index(2004-2006) in Thailand in 1999?
Ensure brevity in your answer.  -12.64. What is the difference between the Production index(2004-2006) of Latin America(all income levels) in 1997 and the Production index(2004-2006) of North America in 1998?
Keep it short and to the point. -16.16. What is the difference between the Production index(2004-2006) in Latin America(all income levels) in 1997 and the Production index(2004-2006) in Bolivia in 1998?
Ensure brevity in your answer.  -1.98. What is the difference between the Production index(2004-2006) in Latin America(all income levels) in 1997 and the Production index(2004-2006) in Thailand in 1998?
Your answer should be very brief. -6.51. What is the difference between the Production index(2004-2006) in North America in 1997 and the Production index(2004-2006) in Bolivia in 1998?
Provide a succinct answer. 12.92. What is the difference between the Production index(2004-2006) of North America in 1997 and the Production index(2004-2006) of Thailand in 1998?
Your response must be concise. 8.39. What is the difference between the Production index(2004-2006) in Bolivia in 1997 and the Production index(2004-2006) in Thailand in 1998?
Offer a very short reply. -6.55. What is the difference between the Production index(2004-2006) in Latin America(all income levels) in 1997 and the Production index(2004-2006) in North America in 1999?
Provide a succinct answer. -18.33. What is the difference between the Production index(2004-2006) in Latin America(all income levels) in 1997 and the Production index(2004-2006) in Bolivia in 1999?
Give a very brief answer. -2.29. What is the difference between the Production index(2004-2006) of Latin America(all income levels) in 1997 and the Production index(2004-2006) of Thailand in 1999?
Offer a very short reply. -10.53. What is the difference between the Production index(2004-2006) in North America in 1997 and the Production index(2004-2006) in Bolivia in 1999?
Ensure brevity in your answer.  12.61. What is the difference between the Production index(2004-2006) in North America in 1997 and the Production index(2004-2006) in Thailand in 1999?
Provide a succinct answer. 4.37. What is the difference between the Production index(2004-2006) of Bolivia in 1997 and the Production index(2004-2006) of Thailand in 1999?
Keep it short and to the point. -10.57. What is the difference between the Production index(2004-2006) of Latin America(all income levels) in 1998 and the Production index(2004-2006) of North America in 1999?
Keep it short and to the point. -17.04. What is the difference between the Production index(2004-2006) in Latin America(all income levels) in 1998 and the Production index(2004-2006) in Bolivia in 1999?
Your answer should be very brief. -1. What is the difference between the Production index(2004-2006) of Latin America(all income levels) in 1998 and the Production index(2004-2006) of Thailand in 1999?
Provide a succinct answer. -9.24. What is the difference between the Production index(2004-2006) in North America in 1998 and the Production index(2004-2006) in Bolivia in 1999?
Your answer should be very brief. 13.87. What is the difference between the Production index(2004-2006) of North America in 1998 and the Production index(2004-2006) of Thailand in 1999?
Provide a succinct answer. 5.63. What is the difference between the Production index(2004-2006) in Bolivia in 1998 and the Production index(2004-2006) in Thailand in 1999?
Make the answer very short. -8.55. What is the average Production index(2004-2006) of Latin America(all income levels) per year?
Ensure brevity in your answer.  71.42. What is the average Production index(2004-2006) of North America per year?
Offer a terse response. 86.64. What is the average Production index(2004-2006) in Bolivia per year?
Provide a succinct answer. 69.6. What is the average Production index(2004-2006) of Thailand per year?
Provide a short and direct response. 81.72. In the year 1992, what is the difference between the Production index(2004-2006) in Latin America(all income levels) and Production index(2004-2006) in North America?
Provide a succinct answer. -20.02. In the year 1992, what is the difference between the Production index(2004-2006) of Latin America(all income levels) and Production index(2004-2006) of Bolivia?
Make the answer very short. 5.86. In the year 1992, what is the difference between the Production index(2004-2006) of Latin America(all income levels) and Production index(2004-2006) of Thailand?
Offer a terse response. -15.53. In the year 1992, what is the difference between the Production index(2004-2006) in North America and Production index(2004-2006) in Bolivia?
Provide a succinct answer. 25.88. In the year 1992, what is the difference between the Production index(2004-2006) in North America and Production index(2004-2006) in Thailand?
Your response must be concise. 4.49. In the year 1992, what is the difference between the Production index(2004-2006) in Bolivia and Production index(2004-2006) in Thailand?
Your answer should be very brief. -21.39. In the year 1993, what is the difference between the Production index(2004-2006) of Latin America(all income levels) and Production index(2004-2006) of North America?
Offer a very short reply. -12.83. In the year 1993, what is the difference between the Production index(2004-2006) of Latin America(all income levels) and Production index(2004-2006) of Bolivia?
Ensure brevity in your answer.  3.73. In the year 1993, what is the difference between the Production index(2004-2006) of Latin America(all income levels) and Production index(2004-2006) of Thailand?
Give a very brief answer. -14.86. In the year 1993, what is the difference between the Production index(2004-2006) of North America and Production index(2004-2006) of Bolivia?
Offer a very short reply. 16.56. In the year 1993, what is the difference between the Production index(2004-2006) of North America and Production index(2004-2006) of Thailand?
Provide a short and direct response. -2.03. In the year 1993, what is the difference between the Production index(2004-2006) in Bolivia and Production index(2004-2006) in Thailand?
Your answer should be compact. -18.59. In the year 1994, what is the difference between the Production index(2004-2006) of Latin America(all income levels) and Production index(2004-2006) of North America?
Ensure brevity in your answer.  -20.07. In the year 1994, what is the difference between the Production index(2004-2006) of Latin America(all income levels) and Production index(2004-2006) of Bolivia?
Keep it short and to the point. 2.39. In the year 1994, what is the difference between the Production index(2004-2006) in Latin America(all income levels) and Production index(2004-2006) in Thailand?
Provide a short and direct response. -12.65. In the year 1994, what is the difference between the Production index(2004-2006) in North America and Production index(2004-2006) in Bolivia?
Offer a terse response. 22.46. In the year 1994, what is the difference between the Production index(2004-2006) in North America and Production index(2004-2006) in Thailand?
Offer a terse response. 7.42. In the year 1994, what is the difference between the Production index(2004-2006) of Bolivia and Production index(2004-2006) of Thailand?
Your answer should be very brief. -15.04. In the year 1995, what is the difference between the Production index(2004-2006) in Latin America(all income levels) and Production index(2004-2006) in North America?
Give a very brief answer. -11.82. In the year 1995, what is the difference between the Production index(2004-2006) of Latin America(all income levels) and Production index(2004-2006) of Bolivia?
Your answer should be very brief. 0.34. In the year 1995, what is the difference between the Production index(2004-2006) of Latin America(all income levels) and Production index(2004-2006) of Thailand?
Your answer should be compact. -9.02. In the year 1995, what is the difference between the Production index(2004-2006) in North America and Production index(2004-2006) in Bolivia?
Give a very brief answer. 12.16. In the year 1995, what is the difference between the Production index(2004-2006) of North America and Production index(2004-2006) of Thailand?
Keep it short and to the point. 2.8. In the year 1995, what is the difference between the Production index(2004-2006) of Bolivia and Production index(2004-2006) of Thailand?
Offer a very short reply. -9.36. In the year 1996, what is the difference between the Production index(2004-2006) of Latin America(all income levels) and Production index(2004-2006) of North America?
Your answer should be compact. -15.01. In the year 1996, what is the difference between the Production index(2004-2006) of Latin America(all income levels) and Production index(2004-2006) of Bolivia?
Ensure brevity in your answer.  -0.95. In the year 1996, what is the difference between the Production index(2004-2006) in Latin America(all income levels) and Production index(2004-2006) in Thailand?
Provide a succinct answer. -10.71. In the year 1996, what is the difference between the Production index(2004-2006) in North America and Production index(2004-2006) in Bolivia?
Keep it short and to the point. 14.07. In the year 1996, what is the difference between the Production index(2004-2006) of North America and Production index(2004-2006) of Thailand?
Give a very brief answer. 4.31. In the year 1996, what is the difference between the Production index(2004-2006) in Bolivia and Production index(2004-2006) in Thailand?
Provide a short and direct response. -9.76. In the year 1997, what is the difference between the Production index(2004-2006) of Latin America(all income levels) and Production index(2004-2006) of North America?
Your answer should be very brief. -14.89. In the year 1997, what is the difference between the Production index(2004-2006) of Latin America(all income levels) and Production index(2004-2006) of Bolivia?
Your answer should be compact. 0.04. In the year 1997, what is the difference between the Production index(2004-2006) in Latin America(all income levels) and Production index(2004-2006) in Thailand?
Offer a very short reply. -10. In the year 1997, what is the difference between the Production index(2004-2006) in North America and Production index(2004-2006) in Bolivia?
Your answer should be very brief. 14.94. In the year 1997, what is the difference between the Production index(2004-2006) of North America and Production index(2004-2006) of Thailand?
Provide a succinct answer. 4.9. In the year 1997, what is the difference between the Production index(2004-2006) in Bolivia and Production index(2004-2006) in Thailand?
Ensure brevity in your answer.  -10.04. In the year 1998, what is the difference between the Production index(2004-2006) of Latin America(all income levels) and Production index(2004-2006) of North America?
Your answer should be very brief. -14.88. In the year 1998, what is the difference between the Production index(2004-2006) of Latin America(all income levels) and Production index(2004-2006) of Bolivia?
Provide a short and direct response. -0.69. In the year 1998, what is the difference between the Production index(2004-2006) in Latin America(all income levels) and Production index(2004-2006) in Thailand?
Provide a short and direct response. -5.22. In the year 1998, what is the difference between the Production index(2004-2006) in North America and Production index(2004-2006) in Bolivia?
Your response must be concise. 14.18. In the year 1998, what is the difference between the Production index(2004-2006) in North America and Production index(2004-2006) in Thailand?
Provide a short and direct response. 9.65. In the year 1998, what is the difference between the Production index(2004-2006) in Bolivia and Production index(2004-2006) in Thailand?
Ensure brevity in your answer.  -4.53. In the year 1999, what is the difference between the Production index(2004-2006) of Latin America(all income levels) and Production index(2004-2006) of North America?
Your answer should be compact. -12.23. In the year 1999, what is the difference between the Production index(2004-2006) of Latin America(all income levels) and Production index(2004-2006) of Bolivia?
Provide a short and direct response. 3.81. In the year 1999, what is the difference between the Production index(2004-2006) of Latin America(all income levels) and Production index(2004-2006) of Thailand?
Give a very brief answer. -4.43. In the year 1999, what is the difference between the Production index(2004-2006) of North America and Production index(2004-2006) of Bolivia?
Make the answer very short. 16.04. In the year 1999, what is the difference between the Production index(2004-2006) of North America and Production index(2004-2006) of Thailand?
Provide a short and direct response. 7.8. In the year 1999, what is the difference between the Production index(2004-2006) in Bolivia and Production index(2004-2006) in Thailand?
Provide a short and direct response. -8.24. What is the ratio of the Production index(2004-2006) of North America in 1992 to that in 1993?
Provide a succinct answer. 1.08. What is the ratio of the Production index(2004-2006) of Bolivia in 1992 to that in 1993?
Provide a short and direct response. 0.95. What is the ratio of the Production index(2004-2006) of Latin America(all income levels) in 1992 to that in 1994?
Your answer should be compact. 0.93. What is the ratio of the Production index(2004-2006) of North America in 1992 to that in 1994?
Your answer should be compact. 0.95. What is the ratio of the Production index(2004-2006) of Bolivia in 1992 to that in 1994?
Your answer should be very brief. 0.88. What is the ratio of the Production index(2004-2006) of Thailand in 1992 to that in 1994?
Your response must be concise. 0.98. What is the ratio of the Production index(2004-2006) in Latin America(all income levels) in 1992 to that in 1995?
Make the answer very short. 0.88. What is the ratio of the Production index(2004-2006) in Bolivia in 1992 to that in 1995?
Offer a very short reply. 0.8. What is the ratio of the Production index(2004-2006) of Thailand in 1992 to that in 1995?
Offer a terse response. 0.98. What is the ratio of the Production index(2004-2006) in Latin America(all income levels) in 1992 to that in 1996?
Give a very brief answer. 0.87. What is the ratio of the Production index(2004-2006) in North America in 1992 to that in 1996?
Your answer should be very brief. 0.95. What is the ratio of the Production index(2004-2006) of Bolivia in 1992 to that in 1996?
Give a very brief answer. 0.78. What is the ratio of the Production index(2004-2006) in Thailand in 1992 to that in 1996?
Offer a terse response. 0.95. What is the ratio of the Production index(2004-2006) of Latin America(all income levels) in 1992 to that in 1997?
Offer a terse response. 0.84. What is the ratio of the Production index(2004-2006) of North America in 1992 to that in 1997?
Provide a short and direct response. 0.92. What is the ratio of the Production index(2004-2006) of Bolivia in 1992 to that in 1997?
Provide a succinct answer. 0.76. What is the ratio of the Production index(2004-2006) of Thailand in 1992 to that in 1997?
Your response must be concise. 0.92. What is the ratio of the Production index(2004-2006) in Latin America(all income levels) in 1992 to that in 1998?
Ensure brevity in your answer.  0.82. What is the ratio of the Production index(2004-2006) of North America in 1992 to that in 1998?
Your answer should be compact. 0.91. What is the ratio of the Production index(2004-2006) in Bolivia in 1992 to that in 1998?
Provide a succinct answer. 0.74. What is the ratio of the Production index(2004-2006) in Thailand in 1992 to that in 1998?
Offer a very short reply. 0.96. What is the ratio of the Production index(2004-2006) in Latin America(all income levels) in 1992 to that in 1999?
Provide a short and direct response. 0.77. What is the ratio of the Production index(2004-2006) in North America in 1992 to that in 1999?
Your answer should be compact. 0.89. What is the ratio of the Production index(2004-2006) of Bolivia in 1992 to that in 1999?
Provide a succinct answer. 0.74. What is the ratio of the Production index(2004-2006) of Thailand in 1992 to that in 1999?
Keep it short and to the point. 0.91. What is the ratio of the Production index(2004-2006) of Latin America(all income levels) in 1993 to that in 1994?
Your answer should be compact. 0.94. What is the ratio of the Production index(2004-2006) of North America in 1993 to that in 1994?
Ensure brevity in your answer.  0.87. What is the ratio of the Production index(2004-2006) of Bolivia in 1993 to that in 1994?
Your answer should be very brief. 0.92. What is the ratio of the Production index(2004-2006) in Thailand in 1993 to that in 1994?
Make the answer very short. 0.98. What is the ratio of the Production index(2004-2006) in Latin America(all income levels) in 1993 to that in 1995?
Keep it short and to the point. 0.89. What is the ratio of the Production index(2004-2006) in North America in 1993 to that in 1995?
Provide a succinct answer. 0.92. What is the ratio of the Production index(2004-2006) of Bolivia in 1993 to that in 1995?
Keep it short and to the point. 0.84. What is the ratio of the Production index(2004-2006) of Thailand in 1993 to that in 1995?
Your answer should be very brief. 0.98. What is the ratio of the Production index(2004-2006) of Latin America(all income levels) in 1993 to that in 1996?
Provide a short and direct response. 0.88. What is the ratio of the Production index(2004-2006) of North America in 1993 to that in 1996?
Provide a succinct answer. 0.88. What is the ratio of the Production index(2004-2006) in Bolivia in 1993 to that in 1996?
Your answer should be compact. 0.82. What is the ratio of the Production index(2004-2006) in Thailand in 1993 to that in 1996?
Your response must be concise. 0.95. What is the ratio of the Production index(2004-2006) of Latin America(all income levels) in 1993 to that in 1997?
Offer a terse response. 0.84. What is the ratio of the Production index(2004-2006) of North America in 1993 to that in 1997?
Ensure brevity in your answer.  0.85. What is the ratio of the Production index(2004-2006) in Bolivia in 1993 to that in 1997?
Provide a succinct answer. 0.8. What is the ratio of the Production index(2004-2006) in Thailand in 1993 to that in 1997?
Provide a short and direct response. 0.92. What is the ratio of the Production index(2004-2006) of Latin America(all income levels) in 1993 to that in 1998?
Ensure brevity in your answer.  0.83. What is the ratio of the Production index(2004-2006) of North America in 1993 to that in 1998?
Offer a very short reply. 0.84. What is the ratio of the Production index(2004-2006) in Bolivia in 1993 to that in 1998?
Provide a succinct answer. 0.78. What is the ratio of the Production index(2004-2006) in Thailand in 1993 to that in 1998?
Your answer should be compact. 0.96. What is the ratio of the Production index(2004-2006) in Latin America(all income levels) in 1993 to that in 1999?
Ensure brevity in your answer.  0.78. What is the ratio of the Production index(2004-2006) of North America in 1993 to that in 1999?
Make the answer very short. 0.82. What is the ratio of the Production index(2004-2006) in Bolivia in 1993 to that in 1999?
Provide a short and direct response. 0.77. What is the ratio of the Production index(2004-2006) of Thailand in 1993 to that in 1999?
Your answer should be very brief. 0.91. What is the ratio of the Production index(2004-2006) in Latin America(all income levels) in 1994 to that in 1995?
Your answer should be compact. 0.95. What is the ratio of the Production index(2004-2006) in North America in 1994 to that in 1995?
Provide a short and direct response. 1.05. What is the ratio of the Production index(2004-2006) in Bolivia in 1994 to that in 1995?
Ensure brevity in your answer.  0.92. What is the ratio of the Production index(2004-2006) in Latin America(all income levels) in 1994 to that in 1996?
Your answer should be compact. 0.94. What is the ratio of the Production index(2004-2006) of North America in 1994 to that in 1996?
Keep it short and to the point. 1. What is the ratio of the Production index(2004-2006) in Bolivia in 1994 to that in 1996?
Give a very brief answer. 0.89. What is the ratio of the Production index(2004-2006) of Thailand in 1994 to that in 1996?
Make the answer very short. 0.97. What is the ratio of the Production index(2004-2006) in Latin America(all income levels) in 1994 to that in 1997?
Give a very brief answer. 0.9. What is the ratio of the Production index(2004-2006) in North America in 1994 to that in 1997?
Your answer should be very brief. 0.97. What is the ratio of the Production index(2004-2006) of Bolivia in 1994 to that in 1997?
Give a very brief answer. 0.87. What is the ratio of the Production index(2004-2006) of Thailand in 1994 to that in 1997?
Give a very brief answer. 0.94. What is the ratio of the Production index(2004-2006) of Latin America(all income levels) in 1994 to that in 1998?
Your response must be concise. 0.88. What is the ratio of the Production index(2004-2006) in North America in 1994 to that in 1998?
Provide a short and direct response. 0.96. What is the ratio of the Production index(2004-2006) of Bolivia in 1994 to that in 1998?
Make the answer very short. 0.84. What is the ratio of the Production index(2004-2006) of Thailand in 1994 to that in 1998?
Keep it short and to the point. 0.98. What is the ratio of the Production index(2004-2006) of Latin America(all income levels) in 1994 to that in 1999?
Provide a short and direct response. 0.83. What is the ratio of the Production index(2004-2006) in North America in 1994 to that in 1999?
Your response must be concise. 0.94. What is the ratio of the Production index(2004-2006) of Bolivia in 1994 to that in 1999?
Make the answer very short. 0.84. What is the ratio of the Production index(2004-2006) of Thailand in 1994 to that in 1999?
Your answer should be compact. 0.93. What is the ratio of the Production index(2004-2006) of Latin America(all income levels) in 1995 to that in 1996?
Ensure brevity in your answer.  0.99. What is the ratio of the Production index(2004-2006) in North America in 1995 to that in 1996?
Your answer should be very brief. 0.95. What is the ratio of the Production index(2004-2006) of Bolivia in 1995 to that in 1996?
Your response must be concise. 0.97. What is the ratio of the Production index(2004-2006) in Thailand in 1995 to that in 1996?
Provide a succinct answer. 0.97. What is the ratio of the Production index(2004-2006) of Latin America(all income levels) in 1995 to that in 1997?
Give a very brief answer. 0.95. What is the ratio of the Production index(2004-2006) of North America in 1995 to that in 1997?
Offer a very short reply. 0.92. What is the ratio of the Production index(2004-2006) in Bolivia in 1995 to that in 1997?
Provide a succinct answer. 0.94. What is the ratio of the Production index(2004-2006) in Thailand in 1995 to that in 1997?
Provide a short and direct response. 0.94. What is the ratio of the Production index(2004-2006) of Latin America(all income levels) in 1995 to that in 1998?
Ensure brevity in your answer.  0.93. What is the ratio of the Production index(2004-2006) in North America in 1995 to that in 1998?
Make the answer very short. 0.91. What is the ratio of the Production index(2004-2006) in Bolivia in 1995 to that in 1998?
Your response must be concise. 0.92. What is the ratio of the Production index(2004-2006) in Thailand in 1995 to that in 1998?
Keep it short and to the point. 0.98. What is the ratio of the Production index(2004-2006) in Latin America(all income levels) in 1995 to that in 1999?
Give a very brief answer. 0.88. What is the ratio of the Production index(2004-2006) of North America in 1995 to that in 1999?
Give a very brief answer. 0.89. What is the ratio of the Production index(2004-2006) of Bolivia in 1995 to that in 1999?
Provide a succinct answer. 0.92. What is the ratio of the Production index(2004-2006) in Thailand in 1995 to that in 1999?
Ensure brevity in your answer.  0.94. What is the ratio of the Production index(2004-2006) of Latin America(all income levels) in 1996 to that in 1997?
Your response must be concise. 0.96. What is the ratio of the Production index(2004-2006) in North America in 1996 to that in 1997?
Offer a very short reply. 0.97. What is the ratio of the Production index(2004-2006) of Bolivia in 1996 to that in 1997?
Your answer should be very brief. 0.97. What is the ratio of the Production index(2004-2006) of Thailand in 1996 to that in 1997?
Provide a succinct answer. 0.97. What is the ratio of the Production index(2004-2006) of Latin America(all income levels) in 1996 to that in 1998?
Your answer should be very brief. 0.94. What is the ratio of the Production index(2004-2006) of North America in 1996 to that in 1998?
Offer a terse response. 0.95. What is the ratio of the Production index(2004-2006) in Bolivia in 1996 to that in 1998?
Your response must be concise. 0.95. What is the ratio of the Production index(2004-2006) of Thailand in 1996 to that in 1998?
Provide a succinct answer. 1.01. What is the ratio of the Production index(2004-2006) of Latin America(all income levels) in 1996 to that in 1999?
Provide a succinct answer. 0.89. What is the ratio of the Production index(2004-2006) of North America in 1996 to that in 1999?
Your answer should be very brief. 0.93. What is the ratio of the Production index(2004-2006) in Bolivia in 1996 to that in 1999?
Offer a very short reply. 0.94. What is the ratio of the Production index(2004-2006) in Thailand in 1996 to that in 1999?
Your answer should be very brief. 0.97. What is the ratio of the Production index(2004-2006) in Latin America(all income levels) in 1997 to that in 1998?
Make the answer very short. 0.98. What is the ratio of the Production index(2004-2006) in North America in 1997 to that in 1998?
Make the answer very short. 0.99. What is the ratio of the Production index(2004-2006) of Bolivia in 1997 to that in 1998?
Your response must be concise. 0.97. What is the ratio of the Production index(2004-2006) in Thailand in 1997 to that in 1998?
Offer a terse response. 1.04. What is the ratio of the Production index(2004-2006) in Latin America(all income levels) in 1997 to that in 1999?
Your answer should be compact. 0.93. What is the ratio of the Production index(2004-2006) of North America in 1997 to that in 1999?
Offer a very short reply. 0.96. What is the ratio of the Production index(2004-2006) in Latin America(all income levels) in 1998 to that in 1999?
Provide a short and direct response. 0.94. What is the ratio of the Production index(2004-2006) of North America in 1998 to that in 1999?
Provide a short and direct response. 0.98. What is the ratio of the Production index(2004-2006) in Thailand in 1998 to that in 1999?
Provide a succinct answer. 0.95. What is the difference between the highest and the second highest Production index(2004-2006) in Latin America(all income levels)?
Offer a very short reply. 4.81. What is the difference between the highest and the second highest Production index(2004-2006) of North America?
Your response must be concise. 2.17. What is the difference between the highest and the second highest Production index(2004-2006) of Bolivia?
Keep it short and to the point. 0.31. What is the difference between the highest and the second highest Production index(2004-2006) of Thailand?
Your answer should be compact. 0.53. What is the difference between the highest and the lowest Production index(2004-2006) of Latin America(all income levels)?
Offer a very short reply. 18.48. What is the difference between the highest and the lowest Production index(2004-2006) in North America?
Your answer should be compact. 17.18. What is the difference between the highest and the lowest Production index(2004-2006) of Bolivia?
Offer a very short reply. 20.53. What is the difference between the highest and the lowest Production index(2004-2006) in Thailand?
Your response must be concise. 7.38. 